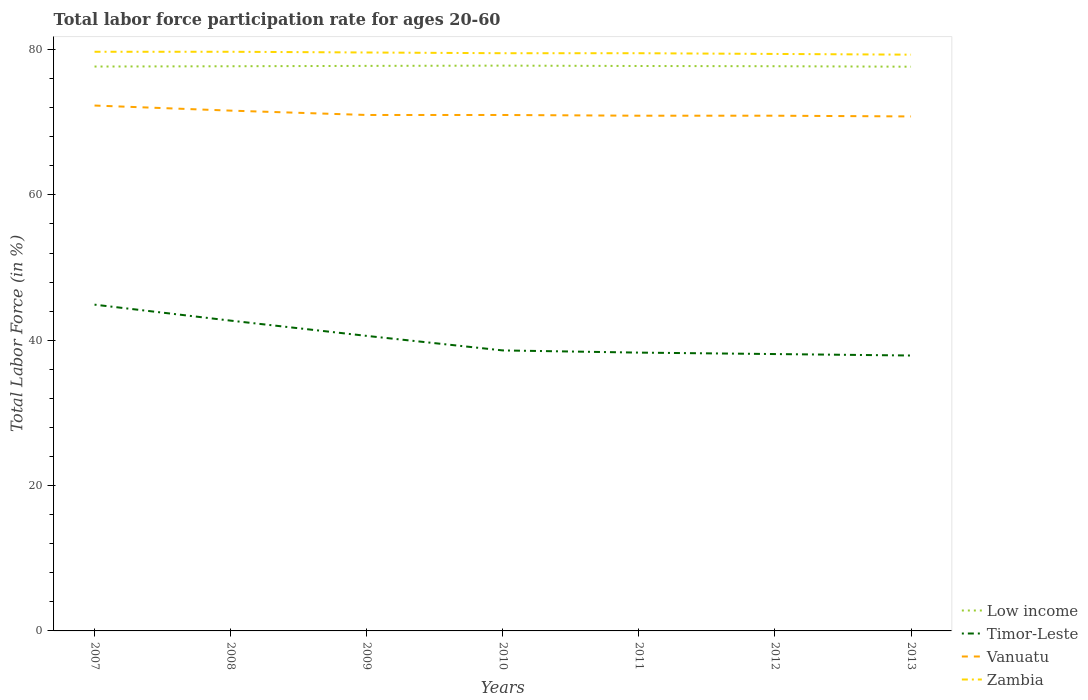How many different coloured lines are there?
Offer a very short reply. 4. Does the line corresponding to Timor-Leste intersect with the line corresponding to Zambia?
Make the answer very short. No. Across all years, what is the maximum labor force participation rate in Zambia?
Offer a terse response. 79.3. What is the total labor force participation rate in Zambia in the graph?
Your answer should be compact. 0.4. What is the difference between the highest and the lowest labor force participation rate in Zambia?
Your response must be concise. 3. Is the labor force participation rate in Vanuatu strictly greater than the labor force participation rate in Zambia over the years?
Your answer should be compact. Yes. How many lines are there?
Keep it short and to the point. 4. Are the values on the major ticks of Y-axis written in scientific E-notation?
Provide a short and direct response. No. Does the graph contain any zero values?
Your answer should be compact. No. How many legend labels are there?
Your response must be concise. 4. How are the legend labels stacked?
Provide a short and direct response. Vertical. What is the title of the graph?
Give a very brief answer. Total labor force participation rate for ages 20-60. Does "Euro area" appear as one of the legend labels in the graph?
Your response must be concise. No. What is the Total Labor Force (in %) in Low income in 2007?
Keep it short and to the point. 77.67. What is the Total Labor Force (in %) of Timor-Leste in 2007?
Provide a short and direct response. 44.9. What is the Total Labor Force (in %) of Vanuatu in 2007?
Offer a terse response. 72.3. What is the Total Labor Force (in %) in Zambia in 2007?
Give a very brief answer. 79.7. What is the Total Labor Force (in %) in Low income in 2008?
Your answer should be very brief. 77.71. What is the Total Labor Force (in %) of Timor-Leste in 2008?
Keep it short and to the point. 42.7. What is the Total Labor Force (in %) in Vanuatu in 2008?
Your answer should be very brief. 71.6. What is the Total Labor Force (in %) in Zambia in 2008?
Your answer should be very brief. 79.7. What is the Total Labor Force (in %) of Low income in 2009?
Offer a very short reply. 77.76. What is the Total Labor Force (in %) of Timor-Leste in 2009?
Offer a terse response. 40.6. What is the Total Labor Force (in %) of Zambia in 2009?
Give a very brief answer. 79.6. What is the Total Labor Force (in %) in Low income in 2010?
Give a very brief answer. 77.79. What is the Total Labor Force (in %) of Timor-Leste in 2010?
Provide a short and direct response. 38.6. What is the Total Labor Force (in %) of Vanuatu in 2010?
Your response must be concise. 71. What is the Total Labor Force (in %) in Zambia in 2010?
Keep it short and to the point. 79.5. What is the Total Labor Force (in %) of Low income in 2011?
Your response must be concise. 77.74. What is the Total Labor Force (in %) of Timor-Leste in 2011?
Your answer should be compact. 38.3. What is the Total Labor Force (in %) of Vanuatu in 2011?
Make the answer very short. 70.9. What is the Total Labor Force (in %) of Zambia in 2011?
Give a very brief answer. 79.5. What is the Total Labor Force (in %) in Low income in 2012?
Offer a terse response. 77.71. What is the Total Labor Force (in %) of Timor-Leste in 2012?
Keep it short and to the point. 38.1. What is the Total Labor Force (in %) of Vanuatu in 2012?
Your answer should be compact. 70.9. What is the Total Labor Force (in %) in Zambia in 2012?
Your answer should be compact. 79.4. What is the Total Labor Force (in %) in Low income in 2013?
Give a very brief answer. 77.64. What is the Total Labor Force (in %) of Timor-Leste in 2013?
Your answer should be very brief. 37.9. What is the Total Labor Force (in %) in Vanuatu in 2013?
Your answer should be very brief. 70.8. What is the Total Labor Force (in %) in Zambia in 2013?
Make the answer very short. 79.3. Across all years, what is the maximum Total Labor Force (in %) of Low income?
Your response must be concise. 77.79. Across all years, what is the maximum Total Labor Force (in %) in Timor-Leste?
Make the answer very short. 44.9. Across all years, what is the maximum Total Labor Force (in %) of Vanuatu?
Your answer should be compact. 72.3. Across all years, what is the maximum Total Labor Force (in %) of Zambia?
Offer a terse response. 79.7. Across all years, what is the minimum Total Labor Force (in %) in Low income?
Provide a short and direct response. 77.64. Across all years, what is the minimum Total Labor Force (in %) of Timor-Leste?
Ensure brevity in your answer.  37.9. Across all years, what is the minimum Total Labor Force (in %) of Vanuatu?
Provide a short and direct response. 70.8. Across all years, what is the minimum Total Labor Force (in %) of Zambia?
Your response must be concise. 79.3. What is the total Total Labor Force (in %) of Low income in the graph?
Your response must be concise. 544.02. What is the total Total Labor Force (in %) of Timor-Leste in the graph?
Your answer should be compact. 281.1. What is the total Total Labor Force (in %) in Vanuatu in the graph?
Offer a very short reply. 498.5. What is the total Total Labor Force (in %) in Zambia in the graph?
Your response must be concise. 556.7. What is the difference between the Total Labor Force (in %) in Low income in 2007 and that in 2008?
Make the answer very short. -0.04. What is the difference between the Total Labor Force (in %) of Timor-Leste in 2007 and that in 2008?
Your response must be concise. 2.2. What is the difference between the Total Labor Force (in %) of Zambia in 2007 and that in 2008?
Make the answer very short. 0. What is the difference between the Total Labor Force (in %) in Low income in 2007 and that in 2009?
Keep it short and to the point. -0.09. What is the difference between the Total Labor Force (in %) of Timor-Leste in 2007 and that in 2009?
Offer a very short reply. 4.3. What is the difference between the Total Labor Force (in %) of Low income in 2007 and that in 2010?
Offer a very short reply. -0.13. What is the difference between the Total Labor Force (in %) in Vanuatu in 2007 and that in 2010?
Provide a succinct answer. 1.3. What is the difference between the Total Labor Force (in %) in Zambia in 2007 and that in 2010?
Keep it short and to the point. 0.2. What is the difference between the Total Labor Force (in %) in Low income in 2007 and that in 2011?
Provide a short and direct response. -0.08. What is the difference between the Total Labor Force (in %) in Timor-Leste in 2007 and that in 2011?
Keep it short and to the point. 6.6. What is the difference between the Total Labor Force (in %) in Vanuatu in 2007 and that in 2011?
Your answer should be very brief. 1.4. What is the difference between the Total Labor Force (in %) of Low income in 2007 and that in 2012?
Your response must be concise. -0.04. What is the difference between the Total Labor Force (in %) in Vanuatu in 2007 and that in 2012?
Your answer should be very brief. 1.4. What is the difference between the Total Labor Force (in %) of Zambia in 2007 and that in 2012?
Ensure brevity in your answer.  0.3. What is the difference between the Total Labor Force (in %) of Low income in 2007 and that in 2013?
Your response must be concise. 0.02. What is the difference between the Total Labor Force (in %) in Timor-Leste in 2007 and that in 2013?
Provide a short and direct response. 7. What is the difference between the Total Labor Force (in %) in Low income in 2008 and that in 2009?
Keep it short and to the point. -0.05. What is the difference between the Total Labor Force (in %) in Timor-Leste in 2008 and that in 2009?
Make the answer very short. 2.1. What is the difference between the Total Labor Force (in %) in Vanuatu in 2008 and that in 2009?
Keep it short and to the point. 0.6. What is the difference between the Total Labor Force (in %) of Zambia in 2008 and that in 2009?
Give a very brief answer. 0.1. What is the difference between the Total Labor Force (in %) in Low income in 2008 and that in 2010?
Ensure brevity in your answer.  -0.09. What is the difference between the Total Labor Force (in %) of Timor-Leste in 2008 and that in 2010?
Ensure brevity in your answer.  4.1. What is the difference between the Total Labor Force (in %) in Zambia in 2008 and that in 2010?
Ensure brevity in your answer.  0.2. What is the difference between the Total Labor Force (in %) in Low income in 2008 and that in 2011?
Keep it short and to the point. -0.04. What is the difference between the Total Labor Force (in %) in Timor-Leste in 2008 and that in 2011?
Offer a terse response. 4.4. What is the difference between the Total Labor Force (in %) of Low income in 2008 and that in 2012?
Make the answer very short. -0. What is the difference between the Total Labor Force (in %) in Timor-Leste in 2008 and that in 2012?
Provide a succinct answer. 4.6. What is the difference between the Total Labor Force (in %) of Vanuatu in 2008 and that in 2012?
Provide a short and direct response. 0.7. What is the difference between the Total Labor Force (in %) in Low income in 2008 and that in 2013?
Your answer should be compact. 0.06. What is the difference between the Total Labor Force (in %) in Timor-Leste in 2008 and that in 2013?
Offer a terse response. 4.8. What is the difference between the Total Labor Force (in %) of Zambia in 2008 and that in 2013?
Your answer should be compact. 0.4. What is the difference between the Total Labor Force (in %) in Low income in 2009 and that in 2010?
Provide a succinct answer. -0.04. What is the difference between the Total Labor Force (in %) of Low income in 2009 and that in 2011?
Your answer should be compact. 0.02. What is the difference between the Total Labor Force (in %) of Timor-Leste in 2009 and that in 2011?
Provide a succinct answer. 2.3. What is the difference between the Total Labor Force (in %) of Vanuatu in 2009 and that in 2011?
Offer a terse response. 0.1. What is the difference between the Total Labor Force (in %) in Zambia in 2009 and that in 2011?
Offer a very short reply. 0.1. What is the difference between the Total Labor Force (in %) in Low income in 2009 and that in 2012?
Offer a very short reply. 0.05. What is the difference between the Total Labor Force (in %) in Timor-Leste in 2009 and that in 2012?
Offer a very short reply. 2.5. What is the difference between the Total Labor Force (in %) in Zambia in 2009 and that in 2012?
Your answer should be very brief. 0.2. What is the difference between the Total Labor Force (in %) of Low income in 2009 and that in 2013?
Provide a succinct answer. 0.11. What is the difference between the Total Labor Force (in %) of Low income in 2010 and that in 2011?
Make the answer very short. 0.05. What is the difference between the Total Labor Force (in %) in Low income in 2010 and that in 2012?
Give a very brief answer. 0.08. What is the difference between the Total Labor Force (in %) of Low income in 2010 and that in 2013?
Provide a succinct answer. 0.15. What is the difference between the Total Labor Force (in %) in Timor-Leste in 2010 and that in 2013?
Ensure brevity in your answer.  0.7. What is the difference between the Total Labor Force (in %) in Zambia in 2010 and that in 2013?
Keep it short and to the point. 0.2. What is the difference between the Total Labor Force (in %) of Low income in 2011 and that in 2012?
Your response must be concise. 0.03. What is the difference between the Total Labor Force (in %) of Vanuatu in 2011 and that in 2012?
Keep it short and to the point. 0. What is the difference between the Total Labor Force (in %) of Zambia in 2011 and that in 2012?
Keep it short and to the point. 0.1. What is the difference between the Total Labor Force (in %) in Low income in 2011 and that in 2013?
Offer a very short reply. 0.1. What is the difference between the Total Labor Force (in %) of Zambia in 2011 and that in 2013?
Ensure brevity in your answer.  0.2. What is the difference between the Total Labor Force (in %) of Low income in 2012 and that in 2013?
Offer a very short reply. 0.06. What is the difference between the Total Labor Force (in %) in Timor-Leste in 2012 and that in 2013?
Make the answer very short. 0.2. What is the difference between the Total Labor Force (in %) in Low income in 2007 and the Total Labor Force (in %) in Timor-Leste in 2008?
Keep it short and to the point. 34.97. What is the difference between the Total Labor Force (in %) in Low income in 2007 and the Total Labor Force (in %) in Vanuatu in 2008?
Offer a terse response. 6.07. What is the difference between the Total Labor Force (in %) in Low income in 2007 and the Total Labor Force (in %) in Zambia in 2008?
Provide a succinct answer. -2.03. What is the difference between the Total Labor Force (in %) of Timor-Leste in 2007 and the Total Labor Force (in %) of Vanuatu in 2008?
Give a very brief answer. -26.7. What is the difference between the Total Labor Force (in %) of Timor-Leste in 2007 and the Total Labor Force (in %) of Zambia in 2008?
Keep it short and to the point. -34.8. What is the difference between the Total Labor Force (in %) of Low income in 2007 and the Total Labor Force (in %) of Timor-Leste in 2009?
Provide a short and direct response. 37.07. What is the difference between the Total Labor Force (in %) of Low income in 2007 and the Total Labor Force (in %) of Vanuatu in 2009?
Provide a short and direct response. 6.67. What is the difference between the Total Labor Force (in %) of Low income in 2007 and the Total Labor Force (in %) of Zambia in 2009?
Offer a terse response. -1.93. What is the difference between the Total Labor Force (in %) of Timor-Leste in 2007 and the Total Labor Force (in %) of Vanuatu in 2009?
Provide a short and direct response. -26.1. What is the difference between the Total Labor Force (in %) of Timor-Leste in 2007 and the Total Labor Force (in %) of Zambia in 2009?
Your response must be concise. -34.7. What is the difference between the Total Labor Force (in %) of Low income in 2007 and the Total Labor Force (in %) of Timor-Leste in 2010?
Offer a terse response. 39.07. What is the difference between the Total Labor Force (in %) in Low income in 2007 and the Total Labor Force (in %) in Vanuatu in 2010?
Offer a terse response. 6.67. What is the difference between the Total Labor Force (in %) of Low income in 2007 and the Total Labor Force (in %) of Zambia in 2010?
Your answer should be compact. -1.83. What is the difference between the Total Labor Force (in %) in Timor-Leste in 2007 and the Total Labor Force (in %) in Vanuatu in 2010?
Your answer should be very brief. -26.1. What is the difference between the Total Labor Force (in %) in Timor-Leste in 2007 and the Total Labor Force (in %) in Zambia in 2010?
Your response must be concise. -34.6. What is the difference between the Total Labor Force (in %) of Low income in 2007 and the Total Labor Force (in %) of Timor-Leste in 2011?
Your response must be concise. 39.37. What is the difference between the Total Labor Force (in %) of Low income in 2007 and the Total Labor Force (in %) of Vanuatu in 2011?
Make the answer very short. 6.77. What is the difference between the Total Labor Force (in %) of Low income in 2007 and the Total Labor Force (in %) of Zambia in 2011?
Make the answer very short. -1.83. What is the difference between the Total Labor Force (in %) of Timor-Leste in 2007 and the Total Labor Force (in %) of Vanuatu in 2011?
Ensure brevity in your answer.  -26. What is the difference between the Total Labor Force (in %) in Timor-Leste in 2007 and the Total Labor Force (in %) in Zambia in 2011?
Keep it short and to the point. -34.6. What is the difference between the Total Labor Force (in %) of Low income in 2007 and the Total Labor Force (in %) of Timor-Leste in 2012?
Your response must be concise. 39.57. What is the difference between the Total Labor Force (in %) in Low income in 2007 and the Total Labor Force (in %) in Vanuatu in 2012?
Your answer should be very brief. 6.77. What is the difference between the Total Labor Force (in %) in Low income in 2007 and the Total Labor Force (in %) in Zambia in 2012?
Give a very brief answer. -1.73. What is the difference between the Total Labor Force (in %) of Timor-Leste in 2007 and the Total Labor Force (in %) of Zambia in 2012?
Ensure brevity in your answer.  -34.5. What is the difference between the Total Labor Force (in %) of Vanuatu in 2007 and the Total Labor Force (in %) of Zambia in 2012?
Keep it short and to the point. -7.1. What is the difference between the Total Labor Force (in %) of Low income in 2007 and the Total Labor Force (in %) of Timor-Leste in 2013?
Your response must be concise. 39.77. What is the difference between the Total Labor Force (in %) in Low income in 2007 and the Total Labor Force (in %) in Vanuatu in 2013?
Your answer should be compact. 6.87. What is the difference between the Total Labor Force (in %) of Low income in 2007 and the Total Labor Force (in %) of Zambia in 2013?
Provide a succinct answer. -1.63. What is the difference between the Total Labor Force (in %) in Timor-Leste in 2007 and the Total Labor Force (in %) in Vanuatu in 2013?
Keep it short and to the point. -25.9. What is the difference between the Total Labor Force (in %) in Timor-Leste in 2007 and the Total Labor Force (in %) in Zambia in 2013?
Ensure brevity in your answer.  -34.4. What is the difference between the Total Labor Force (in %) in Vanuatu in 2007 and the Total Labor Force (in %) in Zambia in 2013?
Keep it short and to the point. -7. What is the difference between the Total Labor Force (in %) in Low income in 2008 and the Total Labor Force (in %) in Timor-Leste in 2009?
Your response must be concise. 37.11. What is the difference between the Total Labor Force (in %) of Low income in 2008 and the Total Labor Force (in %) of Vanuatu in 2009?
Provide a succinct answer. 6.71. What is the difference between the Total Labor Force (in %) in Low income in 2008 and the Total Labor Force (in %) in Zambia in 2009?
Give a very brief answer. -1.89. What is the difference between the Total Labor Force (in %) of Timor-Leste in 2008 and the Total Labor Force (in %) of Vanuatu in 2009?
Offer a terse response. -28.3. What is the difference between the Total Labor Force (in %) of Timor-Leste in 2008 and the Total Labor Force (in %) of Zambia in 2009?
Your response must be concise. -36.9. What is the difference between the Total Labor Force (in %) of Vanuatu in 2008 and the Total Labor Force (in %) of Zambia in 2009?
Keep it short and to the point. -8. What is the difference between the Total Labor Force (in %) of Low income in 2008 and the Total Labor Force (in %) of Timor-Leste in 2010?
Offer a terse response. 39.11. What is the difference between the Total Labor Force (in %) in Low income in 2008 and the Total Labor Force (in %) in Vanuatu in 2010?
Ensure brevity in your answer.  6.71. What is the difference between the Total Labor Force (in %) in Low income in 2008 and the Total Labor Force (in %) in Zambia in 2010?
Keep it short and to the point. -1.79. What is the difference between the Total Labor Force (in %) in Timor-Leste in 2008 and the Total Labor Force (in %) in Vanuatu in 2010?
Offer a terse response. -28.3. What is the difference between the Total Labor Force (in %) of Timor-Leste in 2008 and the Total Labor Force (in %) of Zambia in 2010?
Your answer should be very brief. -36.8. What is the difference between the Total Labor Force (in %) in Low income in 2008 and the Total Labor Force (in %) in Timor-Leste in 2011?
Your response must be concise. 39.41. What is the difference between the Total Labor Force (in %) of Low income in 2008 and the Total Labor Force (in %) of Vanuatu in 2011?
Give a very brief answer. 6.81. What is the difference between the Total Labor Force (in %) of Low income in 2008 and the Total Labor Force (in %) of Zambia in 2011?
Your answer should be compact. -1.79. What is the difference between the Total Labor Force (in %) of Timor-Leste in 2008 and the Total Labor Force (in %) of Vanuatu in 2011?
Ensure brevity in your answer.  -28.2. What is the difference between the Total Labor Force (in %) of Timor-Leste in 2008 and the Total Labor Force (in %) of Zambia in 2011?
Your answer should be very brief. -36.8. What is the difference between the Total Labor Force (in %) in Low income in 2008 and the Total Labor Force (in %) in Timor-Leste in 2012?
Make the answer very short. 39.61. What is the difference between the Total Labor Force (in %) in Low income in 2008 and the Total Labor Force (in %) in Vanuatu in 2012?
Offer a very short reply. 6.81. What is the difference between the Total Labor Force (in %) in Low income in 2008 and the Total Labor Force (in %) in Zambia in 2012?
Make the answer very short. -1.69. What is the difference between the Total Labor Force (in %) of Timor-Leste in 2008 and the Total Labor Force (in %) of Vanuatu in 2012?
Ensure brevity in your answer.  -28.2. What is the difference between the Total Labor Force (in %) of Timor-Leste in 2008 and the Total Labor Force (in %) of Zambia in 2012?
Provide a succinct answer. -36.7. What is the difference between the Total Labor Force (in %) of Low income in 2008 and the Total Labor Force (in %) of Timor-Leste in 2013?
Provide a succinct answer. 39.81. What is the difference between the Total Labor Force (in %) of Low income in 2008 and the Total Labor Force (in %) of Vanuatu in 2013?
Offer a very short reply. 6.91. What is the difference between the Total Labor Force (in %) of Low income in 2008 and the Total Labor Force (in %) of Zambia in 2013?
Your answer should be very brief. -1.59. What is the difference between the Total Labor Force (in %) of Timor-Leste in 2008 and the Total Labor Force (in %) of Vanuatu in 2013?
Give a very brief answer. -28.1. What is the difference between the Total Labor Force (in %) of Timor-Leste in 2008 and the Total Labor Force (in %) of Zambia in 2013?
Give a very brief answer. -36.6. What is the difference between the Total Labor Force (in %) of Low income in 2009 and the Total Labor Force (in %) of Timor-Leste in 2010?
Your answer should be very brief. 39.16. What is the difference between the Total Labor Force (in %) in Low income in 2009 and the Total Labor Force (in %) in Vanuatu in 2010?
Ensure brevity in your answer.  6.76. What is the difference between the Total Labor Force (in %) in Low income in 2009 and the Total Labor Force (in %) in Zambia in 2010?
Give a very brief answer. -1.74. What is the difference between the Total Labor Force (in %) in Timor-Leste in 2009 and the Total Labor Force (in %) in Vanuatu in 2010?
Ensure brevity in your answer.  -30.4. What is the difference between the Total Labor Force (in %) in Timor-Leste in 2009 and the Total Labor Force (in %) in Zambia in 2010?
Offer a terse response. -38.9. What is the difference between the Total Labor Force (in %) in Vanuatu in 2009 and the Total Labor Force (in %) in Zambia in 2010?
Keep it short and to the point. -8.5. What is the difference between the Total Labor Force (in %) in Low income in 2009 and the Total Labor Force (in %) in Timor-Leste in 2011?
Provide a short and direct response. 39.46. What is the difference between the Total Labor Force (in %) in Low income in 2009 and the Total Labor Force (in %) in Vanuatu in 2011?
Provide a succinct answer. 6.86. What is the difference between the Total Labor Force (in %) of Low income in 2009 and the Total Labor Force (in %) of Zambia in 2011?
Provide a succinct answer. -1.74. What is the difference between the Total Labor Force (in %) in Timor-Leste in 2009 and the Total Labor Force (in %) in Vanuatu in 2011?
Your response must be concise. -30.3. What is the difference between the Total Labor Force (in %) in Timor-Leste in 2009 and the Total Labor Force (in %) in Zambia in 2011?
Offer a very short reply. -38.9. What is the difference between the Total Labor Force (in %) of Low income in 2009 and the Total Labor Force (in %) of Timor-Leste in 2012?
Offer a terse response. 39.66. What is the difference between the Total Labor Force (in %) of Low income in 2009 and the Total Labor Force (in %) of Vanuatu in 2012?
Your answer should be compact. 6.86. What is the difference between the Total Labor Force (in %) of Low income in 2009 and the Total Labor Force (in %) of Zambia in 2012?
Make the answer very short. -1.64. What is the difference between the Total Labor Force (in %) in Timor-Leste in 2009 and the Total Labor Force (in %) in Vanuatu in 2012?
Provide a succinct answer. -30.3. What is the difference between the Total Labor Force (in %) of Timor-Leste in 2009 and the Total Labor Force (in %) of Zambia in 2012?
Make the answer very short. -38.8. What is the difference between the Total Labor Force (in %) of Vanuatu in 2009 and the Total Labor Force (in %) of Zambia in 2012?
Offer a very short reply. -8.4. What is the difference between the Total Labor Force (in %) of Low income in 2009 and the Total Labor Force (in %) of Timor-Leste in 2013?
Offer a terse response. 39.86. What is the difference between the Total Labor Force (in %) of Low income in 2009 and the Total Labor Force (in %) of Vanuatu in 2013?
Make the answer very short. 6.96. What is the difference between the Total Labor Force (in %) of Low income in 2009 and the Total Labor Force (in %) of Zambia in 2013?
Your answer should be compact. -1.54. What is the difference between the Total Labor Force (in %) of Timor-Leste in 2009 and the Total Labor Force (in %) of Vanuatu in 2013?
Your answer should be compact. -30.2. What is the difference between the Total Labor Force (in %) in Timor-Leste in 2009 and the Total Labor Force (in %) in Zambia in 2013?
Provide a succinct answer. -38.7. What is the difference between the Total Labor Force (in %) of Low income in 2010 and the Total Labor Force (in %) of Timor-Leste in 2011?
Ensure brevity in your answer.  39.49. What is the difference between the Total Labor Force (in %) in Low income in 2010 and the Total Labor Force (in %) in Vanuatu in 2011?
Give a very brief answer. 6.89. What is the difference between the Total Labor Force (in %) in Low income in 2010 and the Total Labor Force (in %) in Zambia in 2011?
Your response must be concise. -1.71. What is the difference between the Total Labor Force (in %) in Timor-Leste in 2010 and the Total Labor Force (in %) in Vanuatu in 2011?
Offer a terse response. -32.3. What is the difference between the Total Labor Force (in %) of Timor-Leste in 2010 and the Total Labor Force (in %) of Zambia in 2011?
Your answer should be very brief. -40.9. What is the difference between the Total Labor Force (in %) in Low income in 2010 and the Total Labor Force (in %) in Timor-Leste in 2012?
Ensure brevity in your answer.  39.69. What is the difference between the Total Labor Force (in %) of Low income in 2010 and the Total Labor Force (in %) of Vanuatu in 2012?
Make the answer very short. 6.89. What is the difference between the Total Labor Force (in %) in Low income in 2010 and the Total Labor Force (in %) in Zambia in 2012?
Offer a terse response. -1.61. What is the difference between the Total Labor Force (in %) of Timor-Leste in 2010 and the Total Labor Force (in %) of Vanuatu in 2012?
Offer a very short reply. -32.3. What is the difference between the Total Labor Force (in %) of Timor-Leste in 2010 and the Total Labor Force (in %) of Zambia in 2012?
Provide a succinct answer. -40.8. What is the difference between the Total Labor Force (in %) of Vanuatu in 2010 and the Total Labor Force (in %) of Zambia in 2012?
Your answer should be very brief. -8.4. What is the difference between the Total Labor Force (in %) of Low income in 2010 and the Total Labor Force (in %) of Timor-Leste in 2013?
Offer a very short reply. 39.89. What is the difference between the Total Labor Force (in %) in Low income in 2010 and the Total Labor Force (in %) in Vanuatu in 2013?
Your answer should be very brief. 6.99. What is the difference between the Total Labor Force (in %) in Low income in 2010 and the Total Labor Force (in %) in Zambia in 2013?
Keep it short and to the point. -1.51. What is the difference between the Total Labor Force (in %) in Timor-Leste in 2010 and the Total Labor Force (in %) in Vanuatu in 2013?
Your answer should be very brief. -32.2. What is the difference between the Total Labor Force (in %) of Timor-Leste in 2010 and the Total Labor Force (in %) of Zambia in 2013?
Make the answer very short. -40.7. What is the difference between the Total Labor Force (in %) of Vanuatu in 2010 and the Total Labor Force (in %) of Zambia in 2013?
Your answer should be compact. -8.3. What is the difference between the Total Labor Force (in %) of Low income in 2011 and the Total Labor Force (in %) of Timor-Leste in 2012?
Offer a terse response. 39.64. What is the difference between the Total Labor Force (in %) of Low income in 2011 and the Total Labor Force (in %) of Vanuatu in 2012?
Ensure brevity in your answer.  6.84. What is the difference between the Total Labor Force (in %) in Low income in 2011 and the Total Labor Force (in %) in Zambia in 2012?
Offer a very short reply. -1.66. What is the difference between the Total Labor Force (in %) in Timor-Leste in 2011 and the Total Labor Force (in %) in Vanuatu in 2012?
Your answer should be very brief. -32.6. What is the difference between the Total Labor Force (in %) of Timor-Leste in 2011 and the Total Labor Force (in %) of Zambia in 2012?
Offer a very short reply. -41.1. What is the difference between the Total Labor Force (in %) of Vanuatu in 2011 and the Total Labor Force (in %) of Zambia in 2012?
Your response must be concise. -8.5. What is the difference between the Total Labor Force (in %) in Low income in 2011 and the Total Labor Force (in %) in Timor-Leste in 2013?
Provide a short and direct response. 39.84. What is the difference between the Total Labor Force (in %) of Low income in 2011 and the Total Labor Force (in %) of Vanuatu in 2013?
Your response must be concise. 6.94. What is the difference between the Total Labor Force (in %) of Low income in 2011 and the Total Labor Force (in %) of Zambia in 2013?
Offer a very short reply. -1.56. What is the difference between the Total Labor Force (in %) in Timor-Leste in 2011 and the Total Labor Force (in %) in Vanuatu in 2013?
Your answer should be compact. -32.5. What is the difference between the Total Labor Force (in %) of Timor-Leste in 2011 and the Total Labor Force (in %) of Zambia in 2013?
Provide a short and direct response. -41. What is the difference between the Total Labor Force (in %) in Low income in 2012 and the Total Labor Force (in %) in Timor-Leste in 2013?
Your answer should be compact. 39.81. What is the difference between the Total Labor Force (in %) in Low income in 2012 and the Total Labor Force (in %) in Vanuatu in 2013?
Offer a very short reply. 6.91. What is the difference between the Total Labor Force (in %) in Low income in 2012 and the Total Labor Force (in %) in Zambia in 2013?
Offer a terse response. -1.59. What is the difference between the Total Labor Force (in %) in Timor-Leste in 2012 and the Total Labor Force (in %) in Vanuatu in 2013?
Provide a succinct answer. -32.7. What is the difference between the Total Labor Force (in %) of Timor-Leste in 2012 and the Total Labor Force (in %) of Zambia in 2013?
Make the answer very short. -41.2. What is the average Total Labor Force (in %) of Low income per year?
Provide a short and direct response. 77.72. What is the average Total Labor Force (in %) of Timor-Leste per year?
Offer a terse response. 40.16. What is the average Total Labor Force (in %) in Vanuatu per year?
Offer a terse response. 71.21. What is the average Total Labor Force (in %) in Zambia per year?
Provide a succinct answer. 79.53. In the year 2007, what is the difference between the Total Labor Force (in %) in Low income and Total Labor Force (in %) in Timor-Leste?
Give a very brief answer. 32.77. In the year 2007, what is the difference between the Total Labor Force (in %) in Low income and Total Labor Force (in %) in Vanuatu?
Your response must be concise. 5.37. In the year 2007, what is the difference between the Total Labor Force (in %) of Low income and Total Labor Force (in %) of Zambia?
Ensure brevity in your answer.  -2.03. In the year 2007, what is the difference between the Total Labor Force (in %) in Timor-Leste and Total Labor Force (in %) in Vanuatu?
Offer a terse response. -27.4. In the year 2007, what is the difference between the Total Labor Force (in %) of Timor-Leste and Total Labor Force (in %) of Zambia?
Keep it short and to the point. -34.8. In the year 2007, what is the difference between the Total Labor Force (in %) of Vanuatu and Total Labor Force (in %) of Zambia?
Provide a succinct answer. -7.4. In the year 2008, what is the difference between the Total Labor Force (in %) of Low income and Total Labor Force (in %) of Timor-Leste?
Your response must be concise. 35.01. In the year 2008, what is the difference between the Total Labor Force (in %) in Low income and Total Labor Force (in %) in Vanuatu?
Provide a short and direct response. 6.11. In the year 2008, what is the difference between the Total Labor Force (in %) of Low income and Total Labor Force (in %) of Zambia?
Your response must be concise. -1.99. In the year 2008, what is the difference between the Total Labor Force (in %) in Timor-Leste and Total Labor Force (in %) in Vanuatu?
Ensure brevity in your answer.  -28.9. In the year 2008, what is the difference between the Total Labor Force (in %) in Timor-Leste and Total Labor Force (in %) in Zambia?
Provide a short and direct response. -37. In the year 2008, what is the difference between the Total Labor Force (in %) of Vanuatu and Total Labor Force (in %) of Zambia?
Offer a very short reply. -8.1. In the year 2009, what is the difference between the Total Labor Force (in %) in Low income and Total Labor Force (in %) in Timor-Leste?
Your answer should be compact. 37.16. In the year 2009, what is the difference between the Total Labor Force (in %) of Low income and Total Labor Force (in %) of Vanuatu?
Your response must be concise. 6.76. In the year 2009, what is the difference between the Total Labor Force (in %) in Low income and Total Labor Force (in %) in Zambia?
Keep it short and to the point. -1.84. In the year 2009, what is the difference between the Total Labor Force (in %) in Timor-Leste and Total Labor Force (in %) in Vanuatu?
Make the answer very short. -30.4. In the year 2009, what is the difference between the Total Labor Force (in %) in Timor-Leste and Total Labor Force (in %) in Zambia?
Provide a succinct answer. -39. In the year 2010, what is the difference between the Total Labor Force (in %) of Low income and Total Labor Force (in %) of Timor-Leste?
Make the answer very short. 39.19. In the year 2010, what is the difference between the Total Labor Force (in %) in Low income and Total Labor Force (in %) in Vanuatu?
Offer a very short reply. 6.79. In the year 2010, what is the difference between the Total Labor Force (in %) in Low income and Total Labor Force (in %) in Zambia?
Ensure brevity in your answer.  -1.71. In the year 2010, what is the difference between the Total Labor Force (in %) of Timor-Leste and Total Labor Force (in %) of Vanuatu?
Give a very brief answer. -32.4. In the year 2010, what is the difference between the Total Labor Force (in %) in Timor-Leste and Total Labor Force (in %) in Zambia?
Offer a terse response. -40.9. In the year 2010, what is the difference between the Total Labor Force (in %) of Vanuatu and Total Labor Force (in %) of Zambia?
Your response must be concise. -8.5. In the year 2011, what is the difference between the Total Labor Force (in %) of Low income and Total Labor Force (in %) of Timor-Leste?
Make the answer very short. 39.44. In the year 2011, what is the difference between the Total Labor Force (in %) in Low income and Total Labor Force (in %) in Vanuatu?
Give a very brief answer. 6.84. In the year 2011, what is the difference between the Total Labor Force (in %) in Low income and Total Labor Force (in %) in Zambia?
Provide a succinct answer. -1.76. In the year 2011, what is the difference between the Total Labor Force (in %) in Timor-Leste and Total Labor Force (in %) in Vanuatu?
Give a very brief answer. -32.6. In the year 2011, what is the difference between the Total Labor Force (in %) in Timor-Leste and Total Labor Force (in %) in Zambia?
Make the answer very short. -41.2. In the year 2012, what is the difference between the Total Labor Force (in %) of Low income and Total Labor Force (in %) of Timor-Leste?
Give a very brief answer. 39.61. In the year 2012, what is the difference between the Total Labor Force (in %) of Low income and Total Labor Force (in %) of Vanuatu?
Give a very brief answer. 6.81. In the year 2012, what is the difference between the Total Labor Force (in %) in Low income and Total Labor Force (in %) in Zambia?
Your answer should be compact. -1.69. In the year 2012, what is the difference between the Total Labor Force (in %) of Timor-Leste and Total Labor Force (in %) of Vanuatu?
Offer a terse response. -32.8. In the year 2012, what is the difference between the Total Labor Force (in %) of Timor-Leste and Total Labor Force (in %) of Zambia?
Your answer should be compact. -41.3. In the year 2013, what is the difference between the Total Labor Force (in %) of Low income and Total Labor Force (in %) of Timor-Leste?
Offer a terse response. 39.74. In the year 2013, what is the difference between the Total Labor Force (in %) of Low income and Total Labor Force (in %) of Vanuatu?
Offer a very short reply. 6.84. In the year 2013, what is the difference between the Total Labor Force (in %) of Low income and Total Labor Force (in %) of Zambia?
Your answer should be very brief. -1.66. In the year 2013, what is the difference between the Total Labor Force (in %) of Timor-Leste and Total Labor Force (in %) of Vanuatu?
Make the answer very short. -32.9. In the year 2013, what is the difference between the Total Labor Force (in %) of Timor-Leste and Total Labor Force (in %) of Zambia?
Offer a terse response. -41.4. What is the ratio of the Total Labor Force (in %) in Timor-Leste in 2007 to that in 2008?
Keep it short and to the point. 1.05. What is the ratio of the Total Labor Force (in %) of Vanuatu in 2007 to that in 2008?
Offer a terse response. 1.01. What is the ratio of the Total Labor Force (in %) of Timor-Leste in 2007 to that in 2009?
Offer a terse response. 1.11. What is the ratio of the Total Labor Force (in %) in Vanuatu in 2007 to that in 2009?
Your answer should be very brief. 1.02. What is the ratio of the Total Labor Force (in %) in Low income in 2007 to that in 2010?
Your response must be concise. 1. What is the ratio of the Total Labor Force (in %) of Timor-Leste in 2007 to that in 2010?
Make the answer very short. 1.16. What is the ratio of the Total Labor Force (in %) in Vanuatu in 2007 to that in 2010?
Ensure brevity in your answer.  1.02. What is the ratio of the Total Labor Force (in %) of Timor-Leste in 2007 to that in 2011?
Your response must be concise. 1.17. What is the ratio of the Total Labor Force (in %) of Vanuatu in 2007 to that in 2011?
Provide a succinct answer. 1.02. What is the ratio of the Total Labor Force (in %) of Zambia in 2007 to that in 2011?
Ensure brevity in your answer.  1. What is the ratio of the Total Labor Force (in %) in Low income in 2007 to that in 2012?
Give a very brief answer. 1. What is the ratio of the Total Labor Force (in %) of Timor-Leste in 2007 to that in 2012?
Ensure brevity in your answer.  1.18. What is the ratio of the Total Labor Force (in %) of Vanuatu in 2007 to that in 2012?
Your answer should be compact. 1.02. What is the ratio of the Total Labor Force (in %) in Low income in 2007 to that in 2013?
Give a very brief answer. 1. What is the ratio of the Total Labor Force (in %) in Timor-Leste in 2007 to that in 2013?
Your answer should be very brief. 1.18. What is the ratio of the Total Labor Force (in %) in Vanuatu in 2007 to that in 2013?
Your response must be concise. 1.02. What is the ratio of the Total Labor Force (in %) in Low income in 2008 to that in 2009?
Give a very brief answer. 1. What is the ratio of the Total Labor Force (in %) in Timor-Leste in 2008 to that in 2009?
Offer a very short reply. 1.05. What is the ratio of the Total Labor Force (in %) in Vanuatu in 2008 to that in 2009?
Keep it short and to the point. 1.01. What is the ratio of the Total Labor Force (in %) in Timor-Leste in 2008 to that in 2010?
Your answer should be very brief. 1.11. What is the ratio of the Total Labor Force (in %) in Vanuatu in 2008 to that in 2010?
Your answer should be very brief. 1.01. What is the ratio of the Total Labor Force (in %) in Low income in 2008 to that in 2011?
Your answer should be compact. 1. What is the ratio of the Total Labor Force (in %) of Timor-Leste in 2008 to that in 2011?
Provide a succinct answer. 1.11. What is the ratio of the Total Labor Force (in %) in Vanuatu in 2008 to that in 2011?
Keep it short and to the point. 1.01. What is the ratio of the Total Labor Force (in %) of Low income in 2008 to that in 2012?
Your answer should be very brief. 1. What is the ratio of the Total Labor Force (in %) in Timor-Leste in 2008 to that in 2012?
Provide a short and direct response. 1.12. What is the ratio of the Total Labor Force (in %) in Vanuatu in 2008 to that in 2012?
Make the answer very short. 1.01. What is the ratio of the Total Labor Force (in %) of Low income in 2008 to that in 2013?
Keep it short and to the point. 1. What is the ratio of the Total Labor Force (in %) in Timor-Leste in 2008 to that in 2013?
Your response must be concise. 1.13. What is the ratio of the Total Labor Force (in %) of Vanuatu in 2008 to that in 2013?
Provide a succinct answer. 1.01. What is the ratio of the Total Labor Force (in %) in Zambia in 2008 to that in 2013?
Your response must be concise. 1. What is the ratio of the Total Labor Force (in %) of Timor-Leste in 2009 to that in 2010?
Ensure brevity in your answer.  1.05. What is the ratio of the Total Labor Force (in %) of Low income in 2009 to that in 2011?
Ensure brevity in your answer.  1. What is the ratio of the Total Labor Force (in %) of Timor-Leste in 2009 to that in 2011?
Your response must be concise. 1.06. What is the ratio of the Total Labor Force (in %) of Vanuatu in 2009 to that in 2011?
Provide a succinct answer. 1. What is the ratio of the Total Labor Force (in %) of Zambia in 2009 to that in 2011?
Provide a succinct answer. 1. What is the ratio of the Total Labor Force (in %) of Low income in 2009 to that in 2012?
Ensure brevity in your answer.  1. What is the ratio of the Total Labor Force (in %) in Timor-Leste in 2009 to that in 2012?
Offer a terse response. 1.07. What is the ratio of the Total Labor Force (in %) of Zambia in 2009 to that in 2012?
Give a very brief answer. 1. What is the ratio of the Total Labor Force (in %) in Timor-Leste in 2009 to that in 2013?
Your answer should be compact. 1.07. What is the ratio of the Total Labor Force (in %) of Low income in 2010 to that in 2011?
Offer a terse response. 1. What is the ratio of the Total Labor Force (in %) of Timor-Leste in 2010 to that in 2011?
Your answer should be compact. 1.01. What is the ratio of the Total Labor Force (in %) of Vanuatu in 2010 to that in 2011?
Provide a short and direct response. 1. What is the ratio of the Total Labor Force (in %) of Zambia in 2010 to that in 2011?
Keep it short and to the point. 1. What is the ratio of the Total Labor Force (in %) in Timor-Leste in 2010 to that in 2012?
Provide a succinct answer. 1.01. What is the ratio of the Total Labor Force (in %) of Vanuatu in 2010 to that in 2012?
Your answer should be very brief. 1. What is the ratio of the Total Labor Force (in %) of Zambia in 2010 to that in 2012?
Offer a terse response. 1. What is the ratio of the Total Labor Force (in %) of Low income in 2010 to that in 2013?
Provide a succinct answer. 1. What is the ratio of the Total Labor Force (in %) of Timor-Leste in 2010 to that in 2013?
Make the answer very short. 1.02. What is the ratio of the Total Labor Force (in %) in Timor-Leste in 2011 to that in 2012?
Your response must be concise. 1.01. What is the ratio of the Total Labor Force (in %) in Vanuatu in 2011 to that in 2012?
Your answer should be compact. 1. What is the ratio of the Total Labor Force (in %) in Low income in 2011 to that in 2013?
Offer a terse response. 1. What is the ratio of the Total Labor Force (in %) in Timor-Leste in 2011 to that in 2013?
Provide a short and direct response. 1.01. What is the ratio of the Total Labor Force (in %) of Vanuatu in 2011 to that in 2013?
Provide a succinct answer. 1. What is the ratio of the Total Labor Force (in %) of Low income in 2012 to that in 2013?
Offer a terse response. 1. What is the ratio of the Total Labor Force (in %) in Timor-Leste in 2012 to that in 2013?
Ensure brevity in your answer.  1.01. What is the ratio of the Total Labor Force (in %) in Zambia in 2012 to that in 2013?
Your response must be concise. 1. What is the difference between the highest and the second highest Total Labor Force (in %) of Low income?
Your answer should be compact. 0.04. What is the difference between the highest and the second highest Total Labor Force (in %) in Vanuatu?
Your answer should be compact. 0.7. What is the difference between the highest and the second highest Total Labor Force (in %) of Zambia?
Offer a very short reply. 0. What is the difference between the highest and the lowest Total Labor Force (in %) in Low income?
Your answer should be compact. 0.15. What is the difference between the highest and the lowest Total Labor Force (in %) of Timor-Leste?
Provide a succinct answer. 7. 